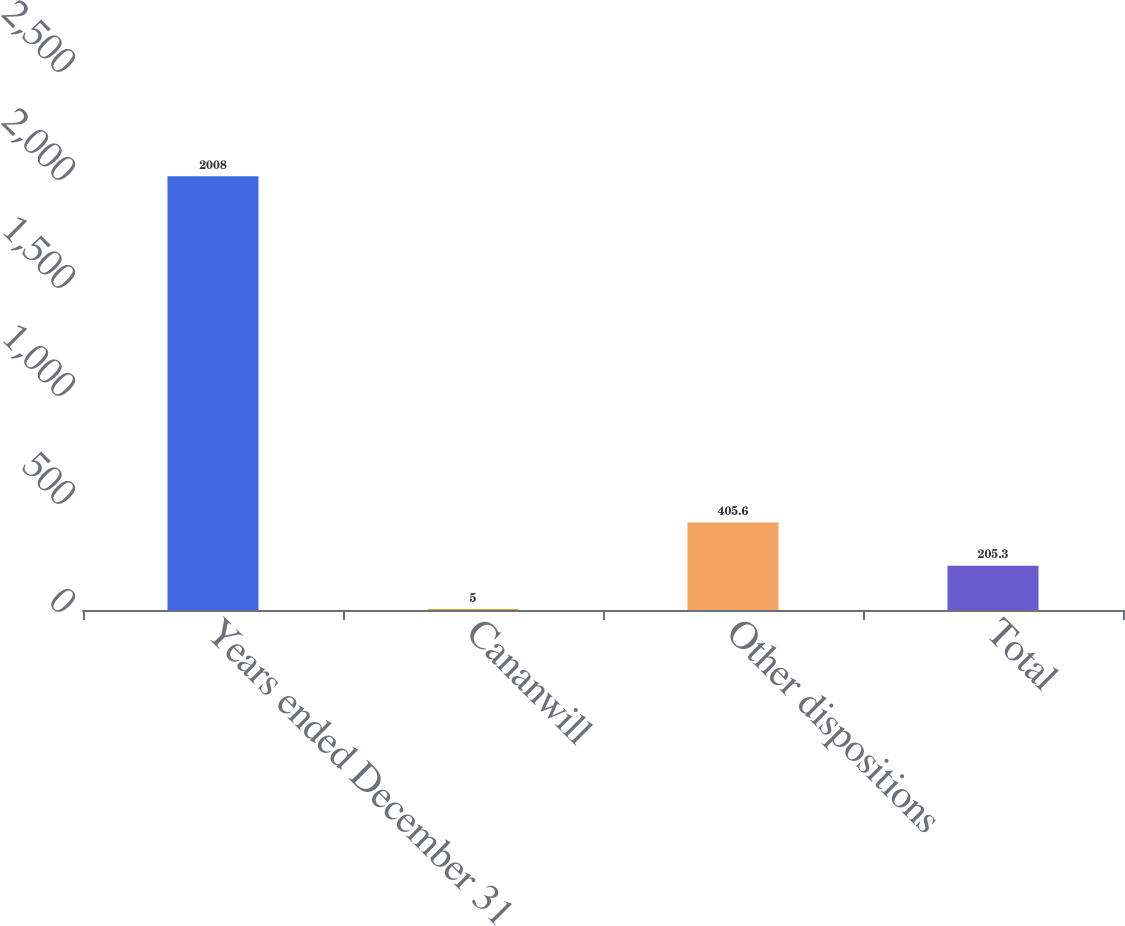Convert chart. <chart><loc_0><loc_0><loc_500><loc_500><bar_chart><fcel>Years ended December 31<fcel>Cananwill<fcel>Other dispositions<fcel>Total<nl><fcel>2008<fcel>5<fcel>405.6<fcel>205.3<nl></chart> 